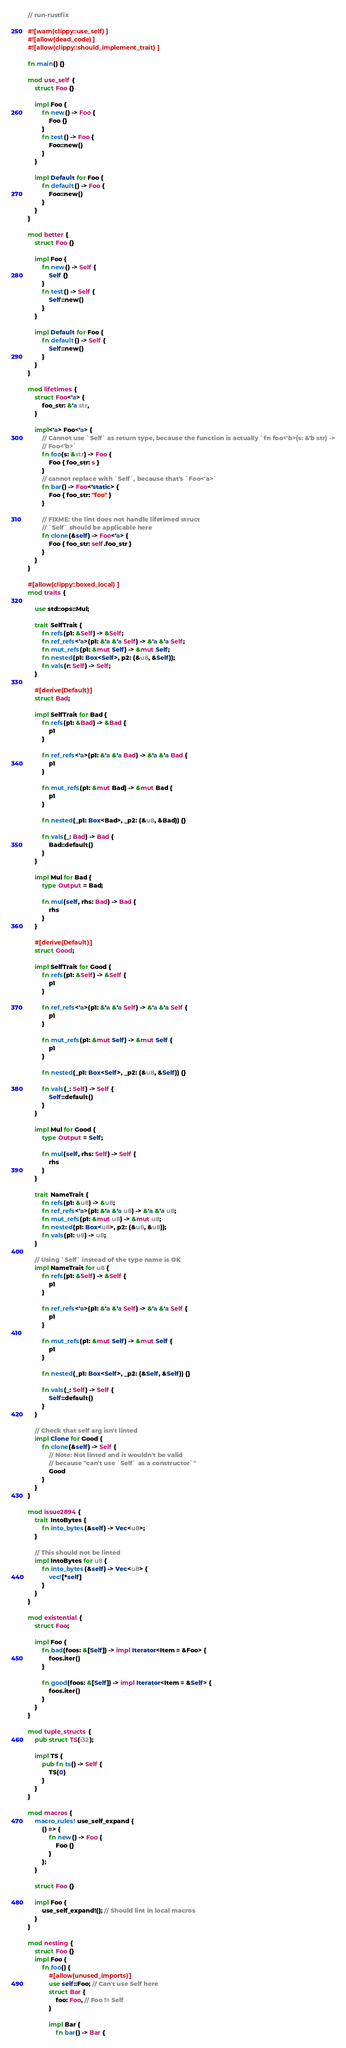Convert code to text. <code><loc_0><loc_0><loc_500><loc_500><_Rust_>// run-rustfix

#![warn(clippy::use_self)]
#![allow(dead_code)]
#![allow(clippy::should_implement_trait)]

fn main() {}

mod use_self {
    struct Foo {}

    impl Foo {
        fn new() -> Foo {
            Foo {}
        }
        fn test() -> Foo {
            Foo::new()
        }
    }

    impl Default for Foo {
        fn default() -> Foo {
            Foo::new()
        }
    }
}

mod better {
    struct Foo {}

    impl Foo {
        fn new() -> Self {
            Self {}
        }
        fn test() -> Self {
            Self::new()
        }
    }

    impl Default for Foo {
        fn default() -> Self {
            Self::new()
        }
    }
}

mod lifetimes {
    struct Foo<'a> {
        foo_str: &'a str,
    }

    impl<'a> Foo<'a> {
        // Cannot use `Self` as return type, because the function is actually `fn foo<'b>(s: &'b str) ->
        // Foo<'b>`
        fn foo(s: &str) -> Foo {
            Foo { foo_str: s }
        }
        // cannot replace with `Self`, because that's `Foo<'a>`
        fn bar() -> Foo<'static> {
            Foo { foo_str: "foo" }
        }

        // FIXME: the lint does not handle lifetimed struct
        // `Self` should be applicable here
        fn clone(&self) -> Foo<'a> {
            Foo { foo_str: self.foo_str }
        }
    }
}

#[allow(clippy::boxed_local)]
mod traits {

    use std::ops::Mul;

    trait SelfTrait {
        fn refs(p1: &Self) -> &Self;
        fn ref_refs<'a>(p1: &'a &'a Self) -> &'a &'a Self;
        fn mut_refs(p1: &mut Self) -> &mut Self;
        fn nested(p1: Box<Self>, p2: (&u8, &Self));
        fn vals(r: Self) -> Self;
    }

    #[derive(Default)]
    struct Bad;

    impl SelfTrait for Bad {
        fn refs(p1: &Bad) -> &Bad {
            p1
        }

        fn ref_refs<'a>(p1: &'a &'a Bad) -> &'a &'a Bad {
            p1
        }

        fn mut_refs(p1: &mut Bad) -> &mut Bad {
            p1
        }

        fn nested(_p1: Box<Bad>, _p2: (&u8, &Bad)) {}

        fn vals(_: Bad) -> Bad {
            Bad::default()
        }
    }

    impl Mul for Bad {
        type Output = Bad;

        fn mul(self, rhs: Bad) -> Bad {
            rhs
        }
    }

    #[derive(Default)]
    struct Good;

    impl SelfTrait for Good {
        fn refs(p1: &Self) -> &Self {
            p1
        }

        fn ref_refs<'a>(p1: &'a &'a Self) -> &'a &'a Self {
            p1
        }

        fn mut_refs(p1: &mut Self) -> &mut Self {
            p1
        }

        fn nested(_p1: Box<Self>, _p2: (&u8, &Self)) {}

        fn vals(_: Self) -> Self {
            Self::default()
        }
    }

    impl Mul for Good {
        type Output = Self;

        fn mul(self, rhs: Self) -> Self {
            rhs
        }
    }

    trait NameTrait {
        fn refs(p1: &u8) -> &u8;
        fn ref_refs<'a>(p1: &'a &'a u8) -> &'a &'a u8;
        fn mut_refs(p1: &mut u8) -> &mut u8;
        fn nested(p1: Box<u8>, p2: (&u8, &u8));
        fn vals(p1: u8) -> u8;
    }

    // Using `Self` instead of the type name is OK
    impl NameTrait for u8 {
        fn refs(p1: &Self) -> &Self {
            p1
        }

        fn ref_refs<'a>(p1: &'a &'a Self) -> &'a &'a Self {
            p1
        }

        fn mut_refs(p1: &mut Self) -> &mut Self {
            p1
        }

        fn nested(_p1: Box<Self>, _p2: (&Self, &Self)) {}

        fn vals(_: Self) -> Self {
            Self::default()
        }
    }

    // Check that self arg isn't linted
    impl Clone for Good {
        fn clone(&self) -> Self {
            // Note: Not linted and it wouldn't be valid
            // because "can't use `Self` as a constructor`"
            Good
        }
    }
}

mod issue2894 {
    trait IntoBytes {
        fn into_bytes(&self) -> Vec<u8>;
    }

    // This should not be linted
    impl IntoBytes for u8 {
        fn into_bytes(&self) -> Vec<u8> {
            vec![*self]
        }
    }
}

mod existential {
    struct Foo;

    impl Foo {
        fn bad(foos: &[Self]) -> impl Iterator<Item = &Foo> {
            foos.iter()
        }

        fn good(foos: &[Self]) -> impl Iterator<Item = &Self> {
            foos.iter()
        }
    }
}

mod tuple_structs {
    pub struct TS(i32);

    impl TS {
        pub fn ts() -> Self {
            TS(0)
        }
    }
}

mod macros {
    macro_rules! use_self_expand {
        () => {
            fn new() -> Foo {
                Foo {}
            }
        };
    }

    struct Foo {}

    impl Foo {
        use_self_expand!(); // Should lint in local macros
    }
}

mod nesting {
    struct Foo {}
    impl Foo {
        fn foo() {
            #[allow(unused_imports)]
            use self::Foo; // Can't use Self here
            struct Bar {
                foo: Foo, // Foo != Self
            }

            impl Bar {
                fn bar() -> Bar {</code> 